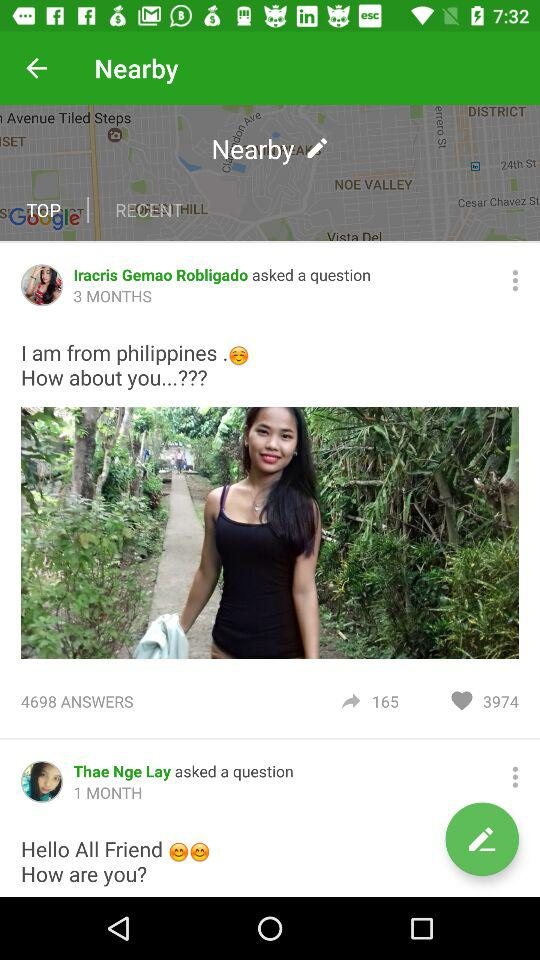How many questions asked by Thae Nge Lay?
Answer the question using a single word or phrase. 1 